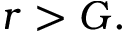<formula> <loc_0><loc_0><loc_500><loc_500>r > G .</formula> 